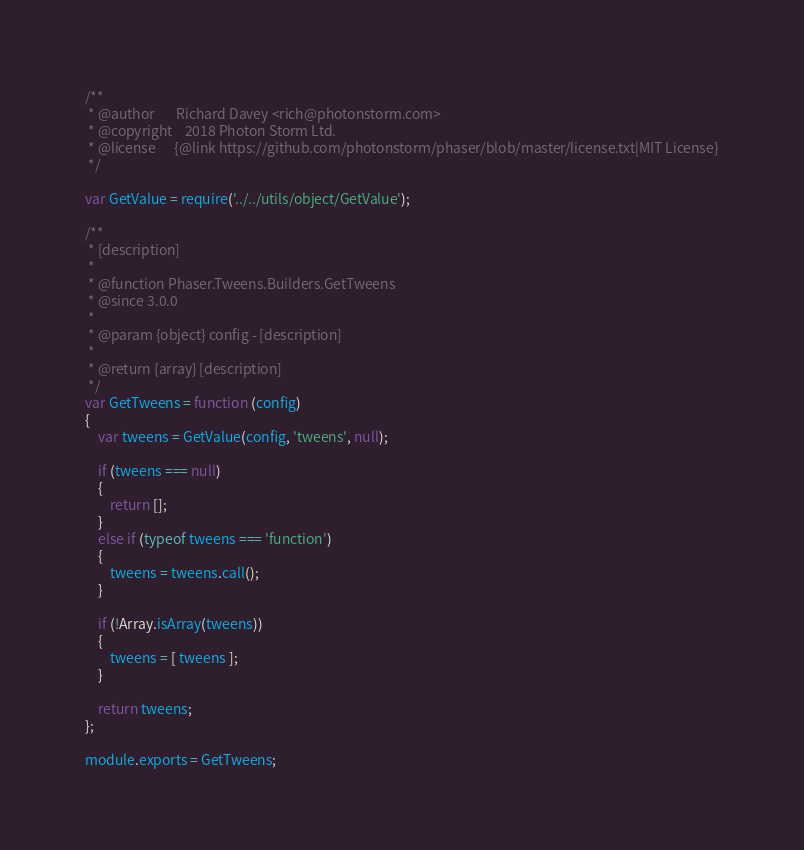<code> <loc_0><loc_0><loc_500><loc_500><_JavaScript_>/**
 * @author       Richard Davey <rich@photonstorm.com>
 * @copyright    2018 Photon Storm Ltd.
 * @license      {@link https://github.com/photonstorm/phaser/blob/master/license.txt|MIT License}
 */

var GetValue = require('../../utils/object/GetValue');

/**
 * [description]
 *
 * @function Phaser.Tweens.Builders.GetTweens
 * @since 3.0.0
 *
 * @param {object} config - [description]
 *
 * @return {array} [description]
 */
var GetTweens = function (config)
{
    var tweens = GetValue(config, 'tweens', null);

    if (tweens === null)
    {
        return [];
    }
    else if (typeof tweens === 'function')
    {
        tweens = tweens.call();
    }

    if (!Array.isArray(tweens))
    {
        tweens = [ tweens ];
    }

    return tweens;
};

module.exports = GetTweens;
</code> 